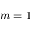<formula> <loc_0><loc_0><loc_500><loc_500>m = 1</formula> 